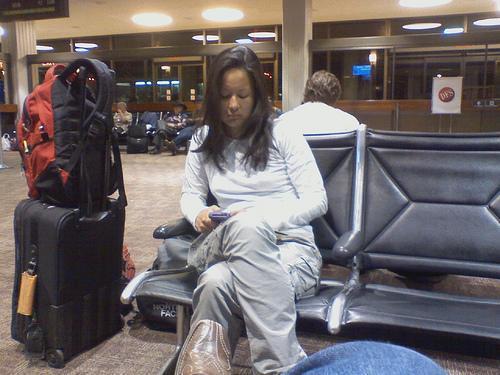How many bags does she have?
Give a very brief answer. 2. How many chairs can you see?
Give a very brief answer. 2. How many people can you see?
Give a very brief answer. 3. 